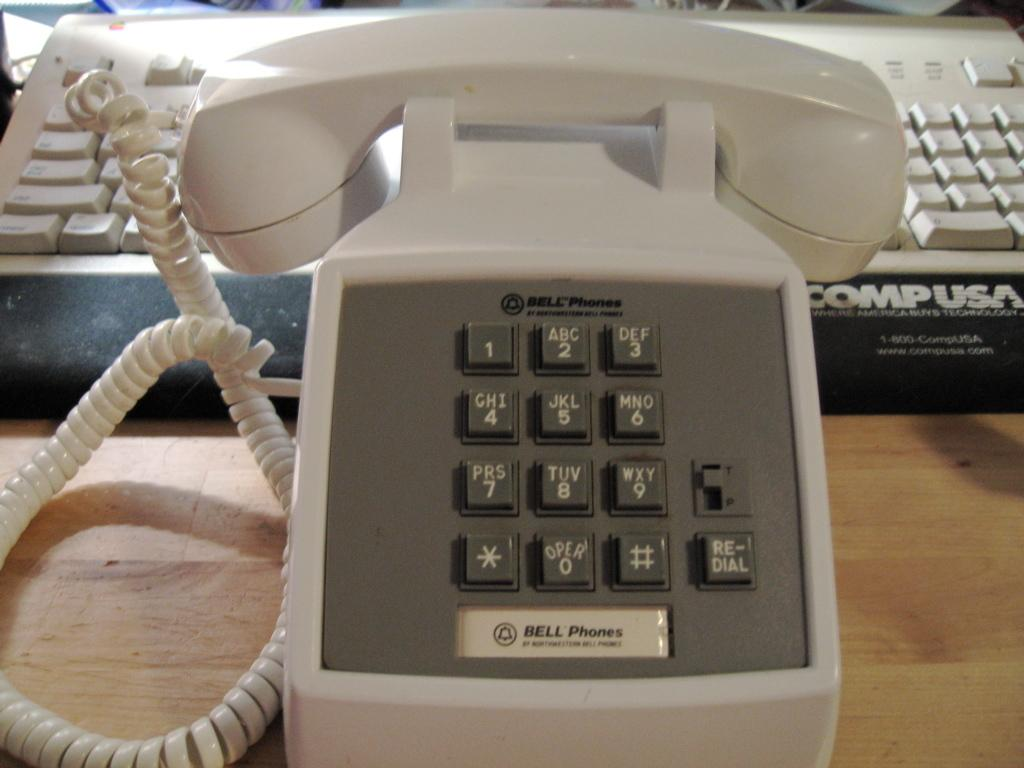What object is located in the foreground of the image? There is a telephone in the foreground of the image. What object is located in the background of the image? There is a keyboard in the background of the image. Where are the fairies flying in the image? There are no fairies present in the image. What position does the telephone hold in relation to the keyboard in the image? The telephone is located in the foreground, while the keyboard is in the background. However, there is no information about their relative positions within those areas. 